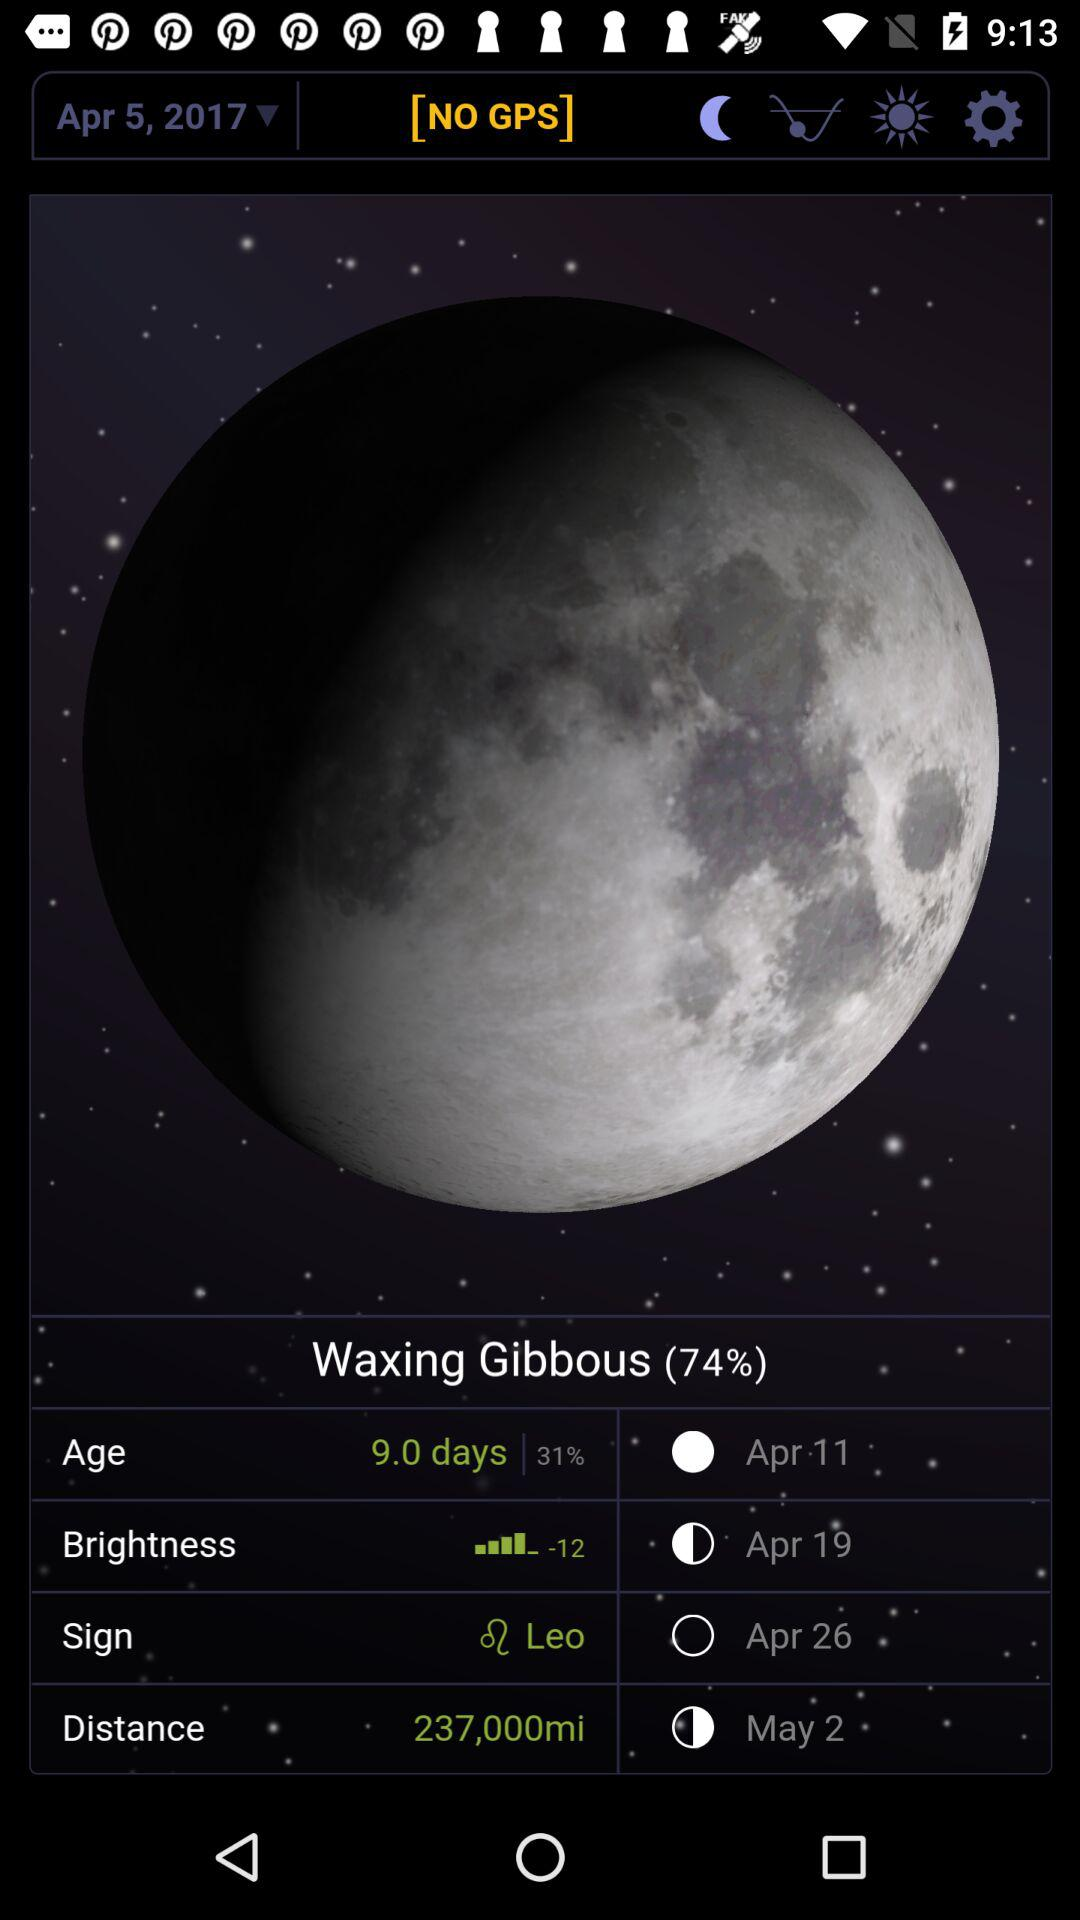What is the distance to the moon in miles?
Answer the question using a single word or phrase. 237,000 